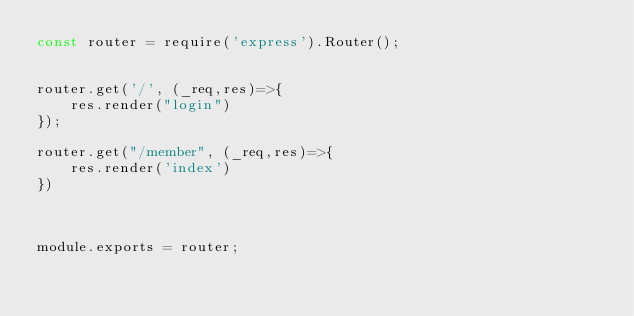Convert code to text. <code><loc_0><loc_0><loc_500><loc_500><_JavaScript_>const router = require('express').Router();


router.get('/', (_req,res)=>{
    res.render("login")
});

router.get("/member", (_req,res)=>{
    res.render('index')
})



module.exports = router;</code> 